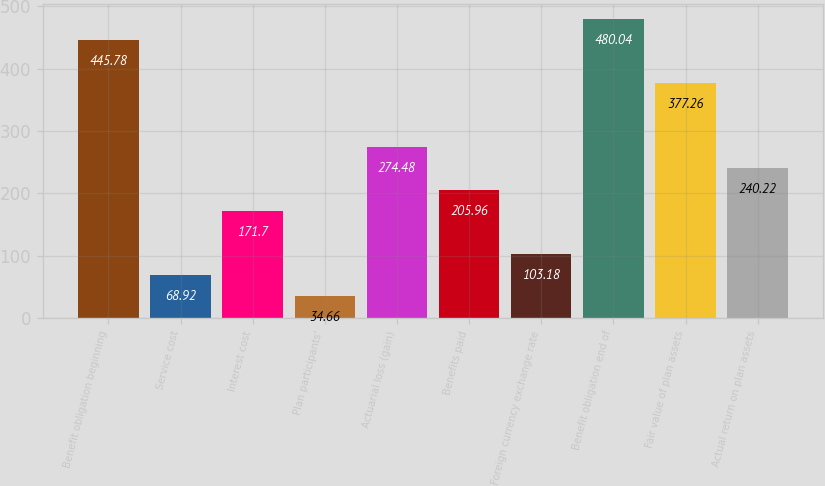Convert chart to OTSL. <chart><loc_0><loc_0><loc_500><loc_500><bar_chart><fcel>Benefit obligation beginning<fcel>Service cost<fcel>Interest cost<fcel>Plan participants'<fcel>Actuarial loss (gain)<fcel>Benefits paid<fcel>Foreign currency exchange rate<fcel>Benefit obligation end of<fcel>Fair value of plan assets<fcel>Actual return on plan assets<nl><fcel>445.78<fcel>68.92<fcel>171.7<fcel>34.66<fcel>274.48<fcel>205.96<fcel>103.18<fcel>480.04<fcel>377.26<fcel>240.22<nl></chart> 